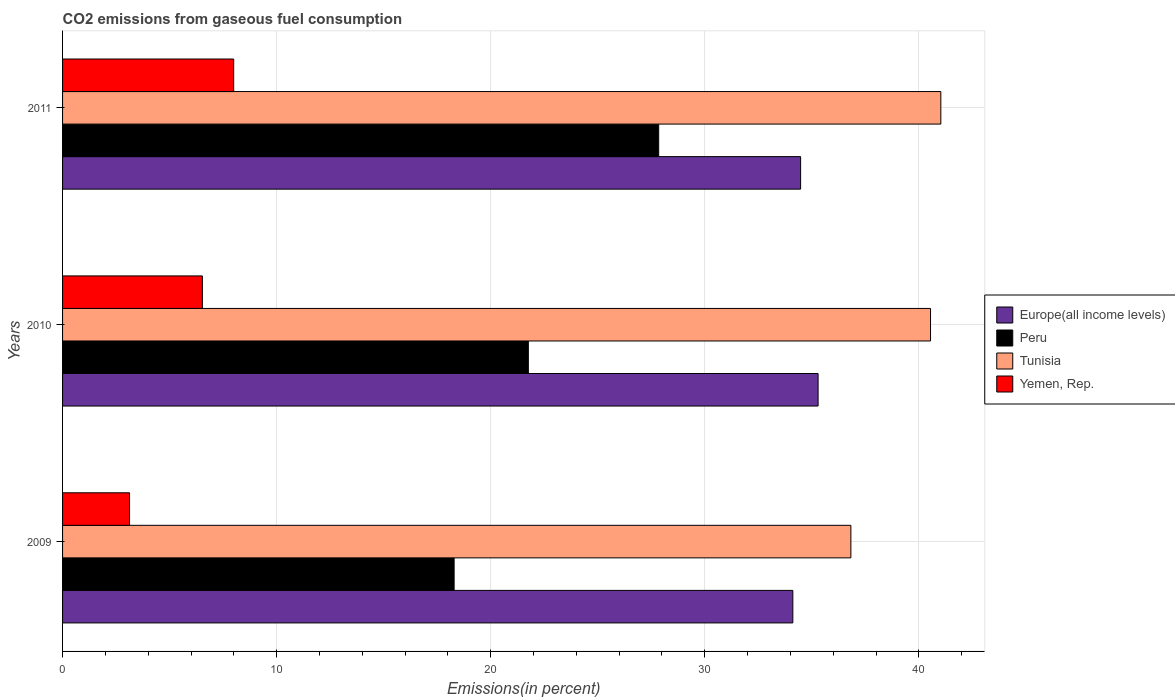How many different coloured bars are there?
Ensure brevity in your answer.  4. How many groups of bars are there?
Your answer should be compact. 3. How many bars are there on the 2nd tick from the top?
Your response must be concise. 4. How many bars are there on the 1st tick from the bottom?
Provide a succinct answer. 4. What is the label of the 3rd group of bars from the top?
Keep it short and to the point. 2009. In how many cases, is the number of bars for a given year not equal to the number of legend labels?
Your answer should be compact. 0. What is the total CO2 emitted in Yemen, Rep. in 2009?
Make the answer very short. 3.13. Across all years, what is the maximum total CO2 emitted in Europe(all income levels)?
Ensure brevity in your answer.  35.29. Across all years, what is the minimum total CO2 emitted in Yemen, Rep.?
Your answer should be very brief. 3.13. In which year was the total CO2 emitted in Europe(all income levels) maximum?
Your response must be concise. 2010. In which year was the total CO2 emitted in Peru minimum?
Give a very brief answer. 2009. What is the total total CO2 emitted in Tunisia in the graph?
Provide a succinct answer. 118.4. What is the difference between the total CO2 emitted in Yemen, Rep. in 2009 and that in 2010?
Offer a very short reply. -3.4. What is the difference between the total CO2 emitted in Europe(all income levels) in 2010 and the total CO2 emitted in Tunisia in 2011?
Your answer should be very brief. -5.73. What is the average total CO2 emitted in Europe(all income levels) per year?
Ensure brevity in your answer.  34.63. In the year 2011, what is the difference between the total CO2 emitted in Tunisia and total CO2 emitted in Yemen, Rep.?
Ensure brevity in your answer.  33.03. In how many years, is the total CO2 emitted in Peru greater than 14 %?
Offer a terse response. 3. What is the ratio of the total CO2 emitted in Yemen, Rep. in 2009 to that in 2011?
Keep it short and to the point. 0.39. Is the total CO2 emitted in Peru in 2010 less than that in 2011?
Keep it short and to the point. Yes. Is the difference between the total CO2 emitted in Tunisia in 2009 and 2010 greater than the difference between the total CO2 emitted in Yemen, Rep. in 2009 and 2010?
Offer a terse response. No. What is the difference between the highest and the second highest total CO2 emitted in Tunisia?
Make the answer very short. 0.48. What is the difference between the highest and the lowest total CO2 emitted in Tunisia?
Your answer should be compact. 4.2. What does the 4th bar from the top in 2010 represents?
Give a very brief answer. Europe(all income levels). Is it the case that in every year, the sum of the total CO2 emitted in Yemen, Rep. and total CO2 emitted in Peru is greater than the total CO2 emitted in Tunisia?
Offer a very short reply. No. How many bars are there?
Make the answer very short. 12. Are all the bars in the graph horizontal?
Your answer should be compact. Yes. Does the graph contain any zero values?
Make the answer very short. No. Does the graph contain grids?
Make the answer very short. Yes. Where does the legend appear in the graph?
Offer a very short reply. Center right. How many legend labels are there?
Provide a succinct answer. 4. How are the legend labels stacked?
Provide a short and direct response. Vertical. What is the title of the graph?
Your response must be concise. CO2 emissions from gaseous fuel consumption. Does "Cyprus" appear as one of the legend labels in the graph?
Your response must be concise. No. What is the label or title of the X-axis?
Your response must be concise. Emissions(in percent). What is the label or title of the Y-axis?
Make the answer very short. Years. What is the Emissions(in percent) of Europe(all income levels) in 2009?
Offer a very short reply. 34.11. What is the Emissions(in percent) of Peru in 2009?
Give a very brief answer. 18.29. What is the Emissions(in percent) of Tunisia in 2009?
Make the answer very short. 36.82. What is the Emissions(in percent) of Yemen, Rep. in 2009?
Ensure brevity in your answer.  3.13. What is the Emissions(in percent) of Europe(all income levels) in 2010?
Provide a succinct answer. 35.29. What is the Emissions(in percent) of Peru in 2010?
Make the answer very short. 21.76. What is the Emissions(in percent) of Tunisia in 2010?
Give a very brief answer. 40.55. What is the Emissions(in percent) in Yemen, Rep. in 2010?
Your answer should be very brief. 6.53. What is the Emissions(in percent) in Europe(all income levels) in 2011?
Give a very brief answer. 34.48. What is the Emissions(in percent) in Peru in 2011?
Offer a terse response. 27.85. What is the Emissions(in percent) in Tunisia in 2011?
Ensure brevity in your answer.  41.03. What is the Emissions(in percent) of Yemen, Rep. in 2011?
Your answer should be compact. 7.99. Across all years, what is the maximum Emissions(in percent) of Europe(all income levels)?
Offer a very short reply. 35.29. Across all years, what is the maximum Emissions(in percent) of Peru?
Provide a short and direct response. 27.85. Across all years, what is the maximum Emissions(in percent) in Tunisia?
Provide a short and direct response. 41.03. Across all years, what is the maximum Emissions(in percent) in Yemen, Rep.?
Keep it short and to the point. 7.99. Across all years, what is the minimum Emissions(in percent) in Europe(all income levels)?
Ensure brevity in your answer.  34.11. Across all years, what is the minimum Emissions(in percent) in Peru?
Keep it short and to the point. 18.29. Across all years, what is the minimum Emissions(in percent) in Tunisia?
Keep it short and to the point. 36.82. Across all years, what is the minimum Emissions(in percent) of Yemen, Rep.?
Offer a terse response. 3.13. What is the total Emissions(in percent) of Europe(all income levels) in the graph?
Ensure brevity in your answer.  103.88. What is the total Emissions(in percent) of Peru in the graph?
Your answer should be compact. 67.9. What is the total Emissions(in percent) of Tunisia in the graph?
Keep it short and to the point. 118.4. What is the total Emissions(in percent) in Yemen, Rep. in the graph?
Your answer should be very brief. 17.65. What is the difference between the Emissions(in percent) in Europe(all income levels) in 2009 and that in 2010?
Offer a very short reply. -1.18. What is the difference between the Emissions(in percent) of Peru in 2009 and that in 2010?
Make the answer very short. -3.47. What is the difference between the Emissions(in percent) in Tunisia in 2009 and that in 2010?
Make the answer very short. -3.72. What is the difference between the Emissions(in percent) of Yemen, Rep. in 2009 and that in 2010?
Make the answer very short. -3.4. What is the difference between the Emissions(in percent) in Europe(all income levels) in 2009 and that in 2011?
Provide a short and direct response. -0.36. What is the difference between the Emissions(in percent) in Peru in 2009 and that in 2011?
Offer a terse response. -9.56. What is the difference between the Emissions(in percent) of Tunisia in 2009 and that in 2011?
Ensure brevity in your answer.  -4.2. What is the difference between the Emissions(in percent) in Yemen, Rep. in 2009 and that in 2011?
Provide a succinct answer. -4.86. What is the difference between the Emissions(in percent) of Europe(all income levels) in 2010 and that in 2011?
Your answer should be very brief. 0.82. What is the difference between the Emissions(in percent) in Peru in 2010 and that in 2011?
Your answer should be very brief. -6.09. What is the difference between the Emissions(in percent) of Tunisia in 2010 and that in 2011?
Provide a short and direct response. -0.48. What is the difference between the Emissions(in percent) of Yemen, Rep. in 2010 and that in 2011?
Provide a succinct answer. -1.46. What is the difference between the Emissions(in percent) of Europe(all income levels) in 2009 and the Emissions(in percent) of Peru in 2010?
Provide a succinct answer. 12.36. What is the difference between the Emissions(in percent) in Europe(all income levels) in 2009 and the Emissions(in percent) in Tunisia in 2010?
Give a very brief answer. -6.43. What is the difference between the Emissions(in percent) in Europe(all income levels) in 2009 and the Emissions(in percent) in Yemen, Rep. in 2010?
Give a very brief answer. 27.58. What is the difference between the Emissions(in percent) of Peru in 2009 and the Emissions(in percent) of Tunisia in 2010?
Make the answer very short. -22.25. What is the difference between the Emissions(in percent) in Peru in 2009 and the Emissions(in percent) in Yemen, Rep. in 2010?
Keep it short and to the point. 11.76. What is the difference between the Emissions(in percent) in Tunisia in 2009 and the Emissions(in percent) in Yemen, Rep. in 2010?
Offer a very short reply. 30.29. What is the difference between the Emissions(in percent) in Europe(all income levels) in 2009 and the Emissions(in percent) in Peru in 2011?
Offer a very short reply. 6.27. What is the difference between the Emissions(in percent) in Europe(all income levels) in 2009 and the Emissions(in percent) in Tunisia in 2011?
Ensure brevity in your answer.  -6.91. What is the difference between the Emissions(in percent) of Europe(all income levels) in 2009 and the Emissions(in percent) of Yemen, Rep. in 2011?
Provide a succinct answer. 26.12. What is the difference between the Emissions(in percent) of Peru in 2009 and the Emissions(in percent) of Tunisia in 2011?
Keep it short and to the point. -22.74. What is the difference between the Emissions(in percent) of Peru in 2009 and the Emissions(in percent) of Yemen, Rep. in 2011?
Offer a terse response. 10.3. What is the difference between the Emissions(in percent) of Tunisia in 2009 and the Emissions(in percent) of Yemen, Rep. in 2011?
Make the answer very short. 28.83. What is the difference between the Emissions(in percent) in Europe(all income levels) in 2010 and the Emissions(in percent) in Peru in 2011?
Make the answer very short. 7.45. What is the difference between the Emissions(in percent) of Europe(all income levels) in 2010 and the Emissions(in percent) of Tunisia in 2011?
Give a very brief answer. -5.73. What is the difference between the Emissions(in percent) in Europe(all income levels) in 2010 and the Emissions(in percent) in Yemen, Rep. in 2011?
Your response must be concise. 27.3. What is the difference between the Emissions(in percent) in Peru in 2010 and the Emissions(in percent) in Tunisia in 2011?
Offer a terse response. -19.27. What is the difference between the Emissions(in percent) of Peru in 2010 and the Emissions(in percent) of Yemen, Rep. in 2011?
Give a very brief answer. 13.76. What is the difference between the Emissions(in percent) in Tunisia in 2010 and the Emissions(in percent) in Yemen, Rep. in 2011?
Keep it short and to the point. 32.55. What is the average Emissions(in percent) in Europe(all income levels) per year?
Offer a terse response. 34.63. What is the average Emissions(in percent) of Peru per year?
Provide a short and direct response. 22.63. What is the average Emissions(in percent) of Tunisia per year?
Your answer should be very brief. 39.47. What is the average Emissions(in percent) of Yemen, Rep. per year?
Make the answer very short. 5.88. In the year 2009, what is the difference between the Emissions(in percent) of Europe(all income levels) and Emissions(in percent) of Peru?
Provide a succinct answer. 15.82. In the year 2009, what is the difference between the Emissions(in percent) in Europe(all income levels) and Emissions(in percent) in Tunisia?
Provide a succinct answer. -2.71. In the year 2009, what is the difference between the Emissions(in percent) of Europe(all income levels) and Emissions(in percent) of Yemen, Rep.?
Your response must be concise. 30.99. In the year 2009, what is the difference between the Emissions(in percent) in Peru and Emissions(in percent) in Tunisia?
Keep it short and to the point. -18.53. In the year 2009, what is the difference between the Emissions(in percent) of Peru and Emissions(in percent) of Yemen, Rep.?
Offer a terse response. 15.16. In the year 2009, what is the difference between the Emissions(in percent) of Tunisia and Emissions(in percent) of Yemen, Rep.?
Your response must be concise. 33.7. In the year 2010, what is the difference between the Emissions(in percent) of Europe(all income levels) and Emissions(in percent) of Peru?
Offer a terse response. 13.53. In the year 2010, what is the difference between the Emissions(in percent) of Europe(all income levels) and Emissions(in percent) of Tunisia?
Provide a short and direct response. -5.25. In the year 2010, what is the difference between the Emissions(in percent) of Europe(all income levels) and Emissions(in percent) of Yemen, Rep.?
Make the answer very short. 28.76. In the year 2010, what is the difference between the Emissions(in percent) of Peru and Emissions(in percent) of Tunisia?
Ensure brevity in your answer.  -18.79. In the year 2010, what is the difference between the Emissions(in percent) in Peru and Emissions(in percent) in Yemen, Rep.?
Ensure brevity in your answer.  15.23. In the year 2010, what is the difference between the Emissions(in percent) of Tunisia and Emissions(in percent) of Yemen, Rep.?
Make the answer very short. 34.02. In the year 2011, what is the difference between the Emissions(in percent) of Europe(all income levels) and Emissions(in percent) of Peru?
Offer a terse response. 6.63. In the year 2011, what is the difference between the Emissions(in percent) of Europe(all income levels) and Emissions(in percent) of Tunisia?
Keep it short and to the point. -6.55. In the year 2011, what is the difference between the Emissions(in percent) in Europe(all income levels) and Emissions(in percent) in Yemen, Rep.?
Offer a terse response. 26.48. In the year 2011, what is the difference between the Emissions(in percent) in Peru and Emissions(in percent) in Tunisia?
Your answer should be very brief. -13.18. In the year 2011, what is the difference between the Emissions(in percent) in Peru and Emissions(in percent) in Yemen, Rep.?
Offer a very short reply. 19.85. In the year 2011, what is the difference between the Emissions(in percent) of Tunisia and Emissions(in percent) of Yemen, Rep.?
Provide a succinct answer. 33.03. What is the ratio of the Emissions(in percent) of Europe(all income levels) in 2009 to that in 2010?
Provide a short and direct response. 0.97. What is the ratio of the Emissions(in percent) in Peru in 2009 to that in 2010?
Provide a short and direct response. 0.84. What is the ratio of the Emissions(in percent) of Tunisia in 2009 to that in 2010?
Offer a very short reply. 0.91. What is the ratio of the Emissions(in percent) of Yemen, Rep. in 2009 to that in 2010?
Your answer should be very brief. 0.48. What is the ratio of the Emissions(in percent) of Peru in 2009 to that in 2011?
Keep it short and to the point. 0.66. What is the ratio of the Emissions(in percent) in Tunisia in 2009 to that in 2011?
Provide a short and direct response. 0.9. What is the ratio of the Emissions(in percent) of Yemen, Rep. in 2009 to that in 2011?
Provide a succinct answer. 0.39. What is the ratio of the Emissions(in percent) of Europe(all income levels) in 2010 to that in 2011?
Ensure brevity in your answer.  1.02. What is the ratio of the Emissions(in percent) in Peru in 2010 to that in 2011?
Your answer should be compact. 0.78. What is the ratio of the Emissions(in percent) in Tunisia in 2010 to that in 2011?
Give a very brief answer. 0.99. What is the ratio of the Emissions(in percent) in Yemen, Rep. in 2010 to that in 2011?
Give a very brief answer. 0.82. What is the difference between the highest and the second highest Emissions(in percent) in Europe(all income levels)?
Make the answer very short. 0.82. What is the difference between the highest and the second highest Emissions(in percent) of Peru?
Your answer should be compact. 6.09. What is the difference between the highest and the second highest Emissions(in percent) of Tunisia?
Your response must be concise. 0.48. What is the difference between the highest and the second highest Emissions(in percent) in Yemen, Rep.?
Provide a short and direct response. 1.46. What is the difference between the highest and the lowest Emissions(in percent) in Europe(all income levels)?
Give a very brief answer. 1.18. What is the difference between the highest and the lowest Emissions(in percent) in Peru?
Give a very brief answer. 9.56. What is the difference between the highest and the lowest Emissions(in percent) of Tunisia?
Offer a very short reply. 4.2. What is the difference between the highest and the lowest Emissions(in percent) of Yemen, Rep.?
Make the answer very short. 4.86. 